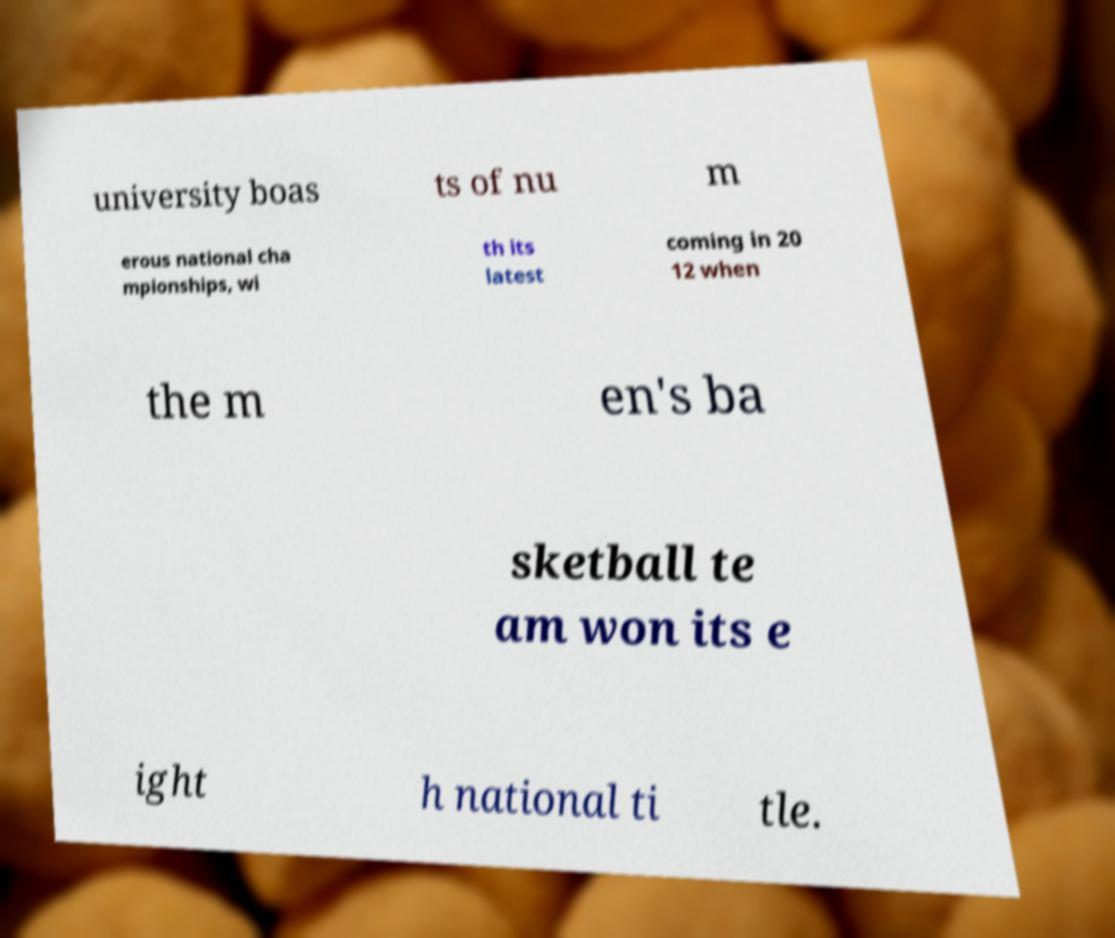For documentation purposes, I need the text within this image transcribed. Could you provide that? university boas ts of nu m erous national cha mpionships, wi th its latest coming in 20 12 when the m en's ba sketball te am won its e ight h national ti tle. 